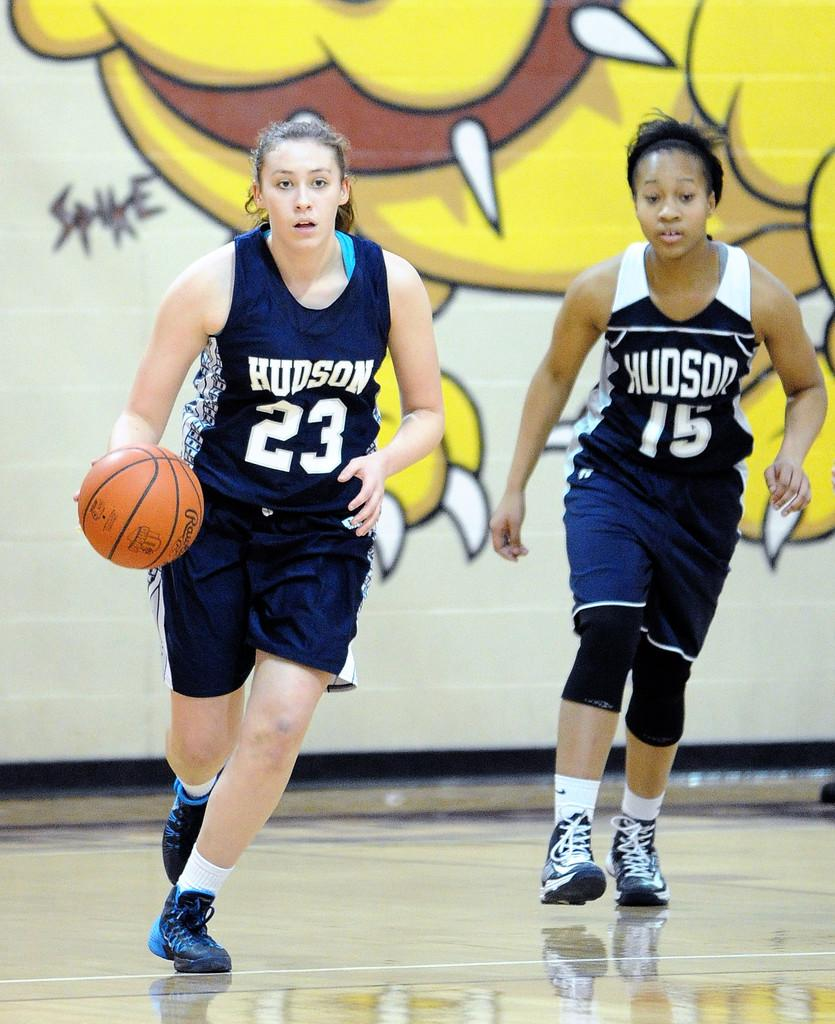How many women are in the image? There are two women in the image. What are the women wearing? The women are wearing navy blue dresses and shoes. What activity are the women engaged in? The women are playing basketball. What can be seen on the wall in the background? There is a dog painting on the wall in the background. What grade does the dog painting represent in the image? There is no indication of a grade or any educational context in the image; it features two women playing basketball and a dog painting on the wall. 